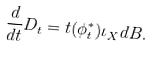<formula> <loc_0><loc_0><loc_500><loc_500>\frac { d } { d t } { D _ { t } } = t ( \phi _ { t } ^ { * } ) \iota _ { X } d B .</formula> 